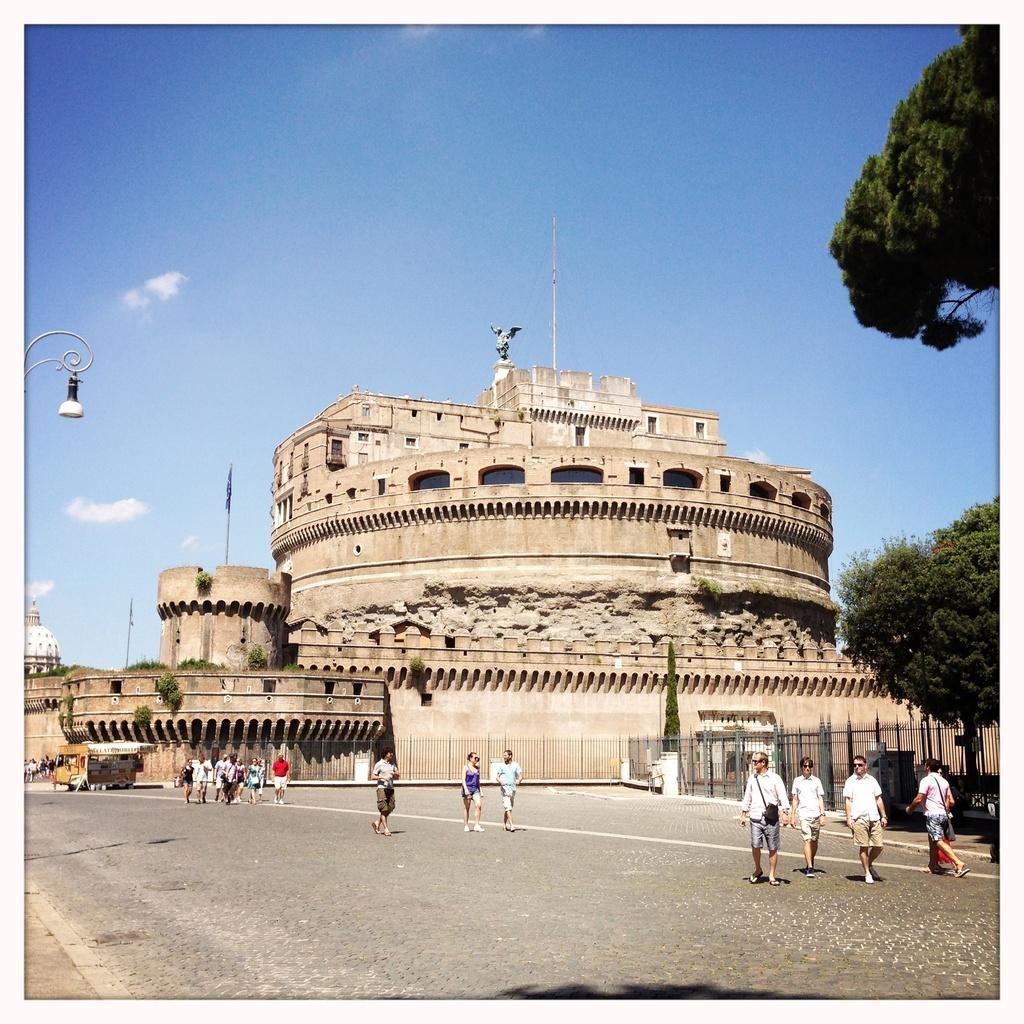Describe this image in one or two sentences. In this picture I can see the monuments. At bottom I can see the three groups of persons who are walking on the road. On the right I can see the cars which are parked near to the fencing and trees. On the left there is a street light. At the top I can see the sky and clouds. 